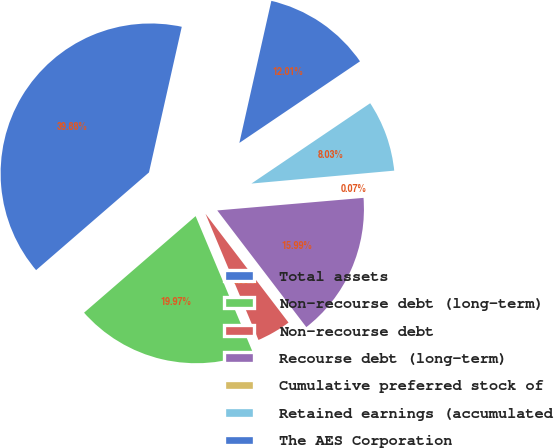Convert chart. <chart><loc_0><loc_0><loc_500><loc_500><pie_chart><fcel>Total assets<fcel>Non-recourse debt (long-term)<fcel>Non-recourse debt<fcel>Recourse debt (long-term)<fcel>Cumulative preferred stock of<fcel>Retained earnings (accumulated<fcel>The AES Corporation<nl><fcel>39.88%<fcel>19.97%<fcel>4.05%<fcel>15.99%<fcel>0.07%<fcel>8.03%<fcel>12.01%<nl></chart> 